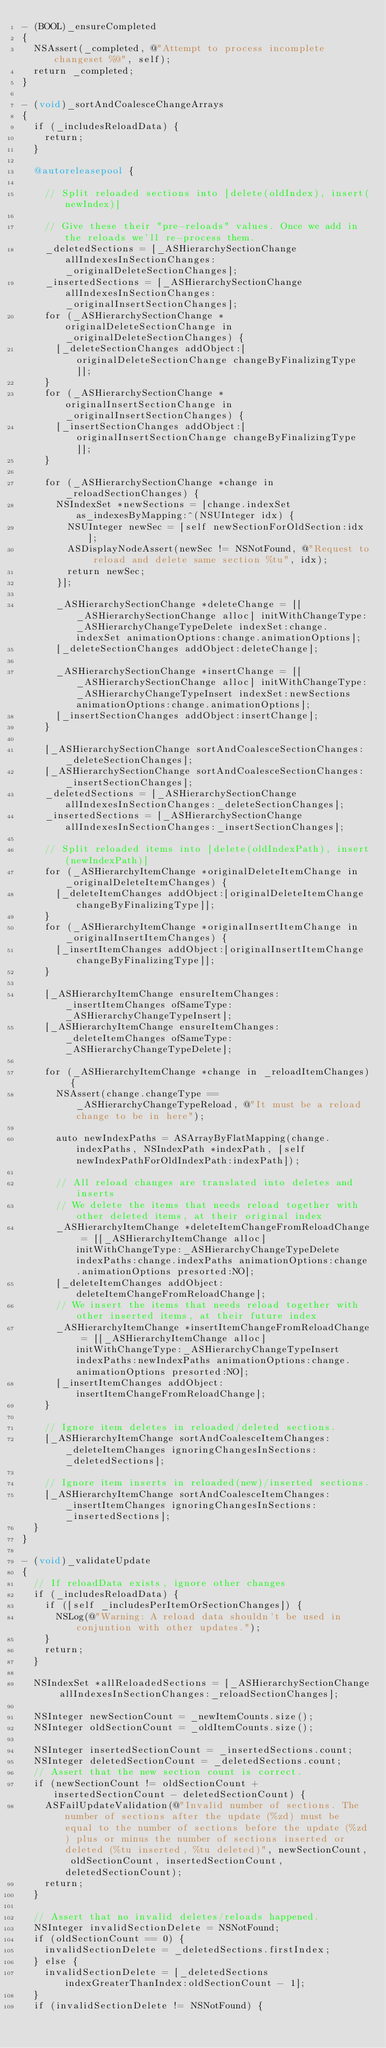Convert code to text. <code><loc_0><loc_0><loc_500><loc_500><_ObjectiveC_>- (BOOL)_ensureCompleted
{
  NSAssert(_completed, @"Attempt to process incomplete changeset %@", self);
  return _completed;
}

- (void)_sortAndCoalesceChangeArrays
{
  if (_includesReloadData) {
    return;
  }
  
  @autoreleasepool {

    // Split reloaded sections into [delete(oldIndex), insert(newIndex)]
    
    // Give these their "pre-reloads" values. Once we add in the reloads we'll re-process them.
    _deletedSections = [_ASHierarchySectionChange allIndexesInSectionChanges:_originalDeleteSectionChanges];
    _insertedSections = [_ASHierarchySectionChange allIndexesInSectionChanges:_originalInsertSectionChanges];
    for (_ASHierarchySectionChange *originalDeleteSectionChange in _originalDeleteSectionChanges) {
      [_deleteSectionChanges addObject:[originalDeleteSectionChange changeByFinalizingType]];
    }
    for (_ASHierarchySectionChange *originalInsertSectionChange in _originalInsertSectionChanges) {
      [_insertSectionChanges addObject:[originalInsertSectionChange changeByFinalizingType]];
    }
    
    for (_ASHierarchySectionChange *change in _reloadSectionChanges) {
      NSIndexSet *newSections = [change.indexSet as_indexesByMapping:^(NSUInteger idx) {
        NSUInteger newSec = [self newSectionForOldSection:idx];
        ASDisplayNodeAssert(newSec != NSNotFound, @"Request to reload and delete same section %tu", idx);
        return newSec;
      }];
      
      _ASHierarchySectionChange *deleteChange = [[_ASHierarchySectionChange alloc] initWithChangeType:_ASHierarchyChangeTypeDelete indexSet:change.indexSet animationOptions:change.animationOptions];
      [_deleteSectionChanges addObject:deleteChange];
      
      _ASHierarchySectionChange *insertChange = [[_ASHierarchySectionChange alloc] initWithChangeType:_ASHierarchyChangeTypeInsert indexSet:newSections animationOptions:change.animationOptions];
      [_insertSectionChanges addObject:insertChange];
    }
    
    [_ASHierarchySectionChange sortAndCoalesceSectionChanges:_deleteSectionChanges];
    [_ASHierarchySectionChange sortAndCoalesceSectionChanges:_insertSectionChanges];
    _deletedSections = [_ASHierarchySectionChange allIndexesInSectionChanges:_deleteSectionChanges];
    _insertedSections = [_ASHierarchySectionChange allIndexesInSectionChanges:_insertSectionChanges];

    // Split reloaded items into [delete(oldIndexPath), insert(newIndexPath)]
    for (_ASHierarchyItemChange *originalDeleteItemChange in _originalDeleteItemChanges) {
      [_deleteItemChanges addObject:[originalDeleteItemChange changeByFinalizingType]];
    }
    for (_ASHierarchyItemChange *originalInsertItemChange in _originalInsertItemChanges) {
      [_insertItemChanges addObject:[originalInsertItemChange changeByFinalizingType]];
    }
    
    [_ASHierarchyItemChange ensureItemChanges:_insertItemChanges ofSameType:_ASHierarchyChangeTypeInsert];
    [_ASHierarchyItemChange ensureItemChanges:_deleteItemChanges ofSameType:_ASHierarchyChangeTypeDelete];
    
    for (_ASHierarchyItemChange *change in _reloadItemChanges) {
      NSAssert(change.changeType == _ASHierarchyChangeTypeReload, @"It must be a reload change to be in here");

      auto newIndexPaths = ASArrayByFlatMapping(change.indexPaths, NSIndexPath *indexPath, [self newIndexPathForOldIndexPath:indexPath]);
      
      // All reload changes are translated into deletes and inserts
      // We delete the items that needs reload together with other deleted items, at their original index
      _ASHierarchyItemChange *deleteItemChangeFromReloadChange = [[_ASHierarchyItemChange alloc] initWithChangeType:_ASHierarchyChangeTypeDelete indexPaths:change.indexPaths animationOptions:change.animationOptions presorted:NO];
      [_deleteItemChanges addObject:deleteItemChangeFromReloadChange];
      // We insert the items that needs reload together with other inserted items, at their future index
      _ASHierarchyItemChange *insertItemChangeFromReloadChange = [[_ASHierarchyItemChange alloc] initWithChangeType:_ASHierarchyChangeTypeInsert indexPaths:newIndexPaths animationOptions:change.animationOptions presorted:NO];
      [_insertItemChanges addObject:insertItemChangeFromReloadChange];
    }
    
    // Ignore item deletes in reloaded/deleted sections.
    [_ASHierarchyItemChange sortAndCoalesceItemChanges:_deleteItemChanges ignoringChangesInSections:_deletedSections];

    // Ignore item inserts in reloaded(new)/inserted sections.
    [_ASHierarchyItemChange sortAndCoalesceItemChanges:_insertItemChanges ignoringChangesInSections:_insertedSections];
  }
}

- (void)_validateUpdate
{
  // If reloadData exists, ignore other changes
  if (_includesReloadData) {
    if ([self _includesPerItemOrSectionChanges]) {
      NSLog(@"Warning: A reload data shouldn't be used in conjuntion with other updates.");
    }
    return;
  }
  
  NSIndexSet *allReloadedSections = [_ASHierarchySectionChange allIndexesInSectionChanges:_reloadSectionChanges];
  
  NSInteger newSectionCount = _newItemCounts.size();
  NSInteger oldSectionCount = _oldItemCounts.size();
  
  NSInteger insertedSectionCount = _insertedSections.count;
  NSInteger deletedSectionCount = _deletedSections.count;
  // Assert that the new section count is correct.
  if (newSectionCount != oldSectionCount + insertedSectionCount - deletedSectionCount) {
    ASFailUpdateValidation(@"Invalid number of sections. The number of sections after the update (%zd) must be equal to the number of sections before the update (%zd) plus or minus the number of sections inserted or deleted (%tu inserted, %tu deleted)", newSectionCount, oldSectionCount, insertedSectionCount, deletedSectionCount);
    return;
  }
  
  // Assert that no invalid deletes/reloads happened.
  NSInteger invalidSectionDelete = NSNotFound;
  if (oldSectionCount == 0) {
    invalidSectionDelete = _deletedSections.firstIndex;
  } else {
    invalidSectionDelete = [_deletedSections indexGreaterThanIndex:oldSectionCount - 1];
  }
  if (invalidSectionDelete != NSNotFound) {</code> 